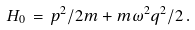<formula> <loc_0><loc_0><loc_500><loc_500>H _ { 0 } \, = \, p ^ { 2 } / 2 m + m \omega ^ { 2 } q ^ { 2 } / 2 \, .</formula> 